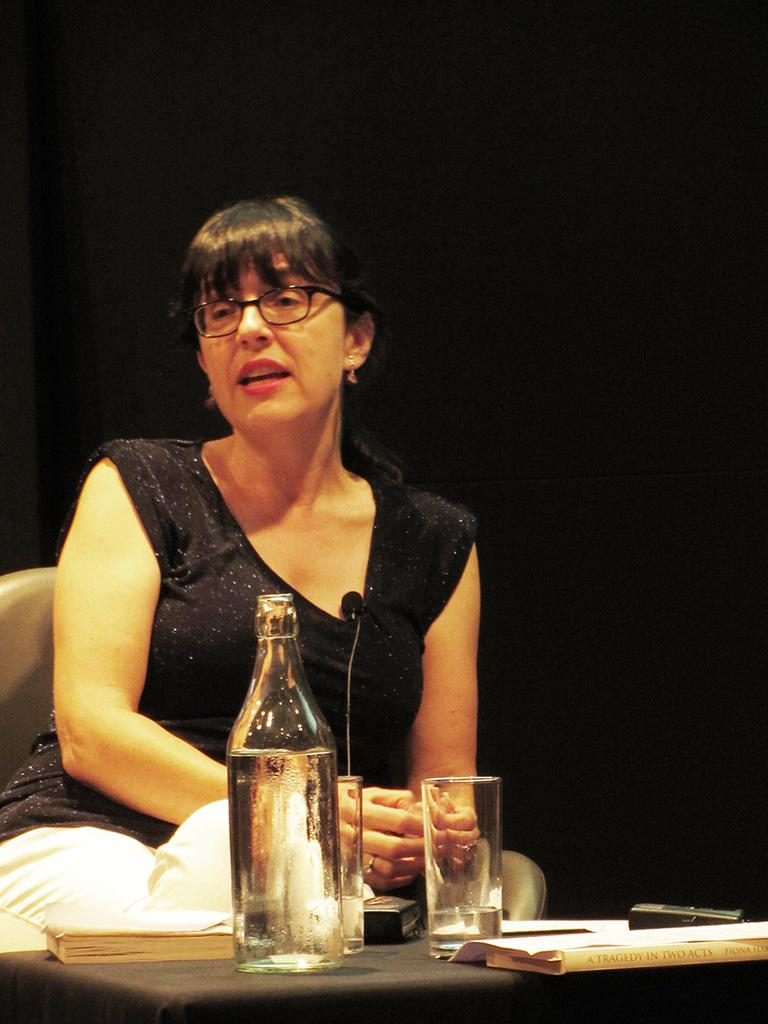Who is the main subject in the image? There is a woman in the image. What is the woman doing in the image? The woman is sitting in front of a table. What can be seen on the table in the image? There is a glass bottle and a glass on the table, along with other objects. What does the caption say about the woman in the image? There is no caption present in the image, so it is not possible to answer that question. 